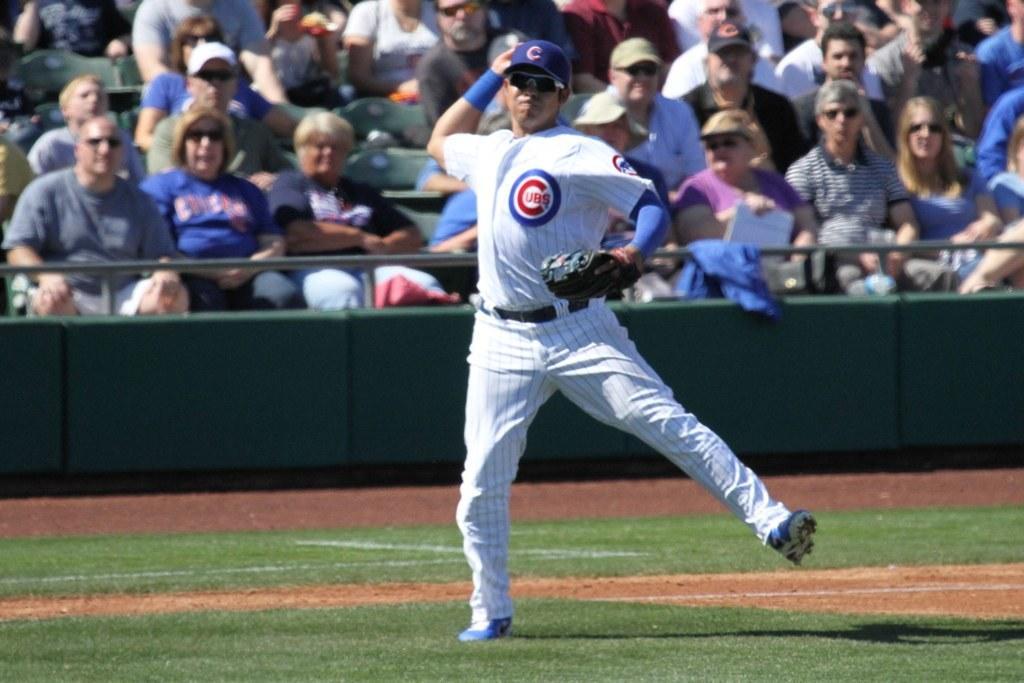Describe this image in one or two sentences. In the picture there is a man he is standing and throwing something. He is wearing a glove to his left hand, behind the man there are many spectators. 